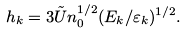<formula> <loc_0><loc_0><loc_500><loc_500>h _ { k } = 3 \tilde { U } n _ { 0 } ^ { 1 / 2 } ( E _ { k } / \varepsilon _ { k } ) ^ { 1 / 2 } .</formula> 